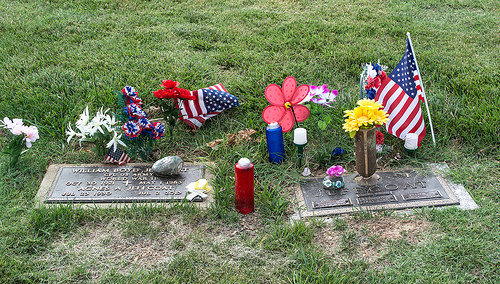<image>
Is the flower behind the flag? No. The flower is not behind the flag. From this viewpoint, the flower appears to be positioned elsewhere in the scene. 